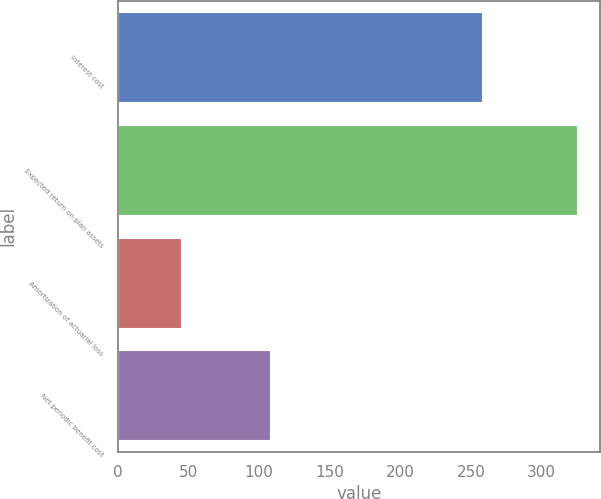<chart> <loc_0><loc_0><loc_500><loc_500><bar_chart><fcel>Interest cost<fcel>Expected return on plan assets<fcel>Amortization of actuarial loss<fcel>Net periodic benefit cost<nl><fcel>258<fcel>325<fcel>45<fcel>108<nl></chart> 